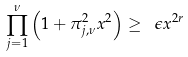Convert formula to latex. <formula><loc_0><loc_0><loc_500><loc_500>\prod _ { j = 1 } ^ { \nu } \left ( 1 + \pi _ { j , \nu } ^ { 2 } x ^ { 2 } \right ) \geq \ \epsilon x ^ { 2 r }</formula> 